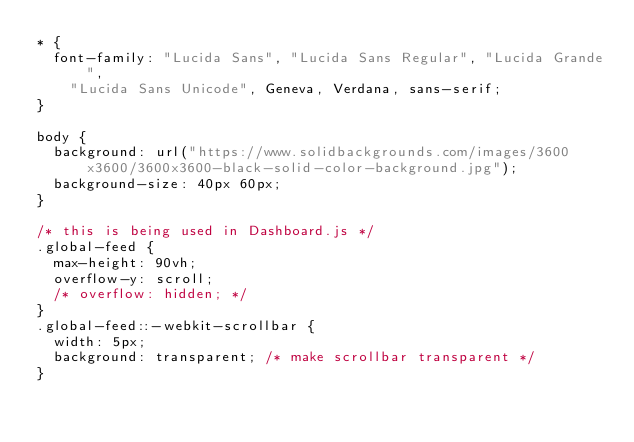<code> <loc_0><loc_0><loc_500><loc_500><_CSS_>* {
  font-family: "Lucida Sans", "Lucida Sans Regular", "Lucida Grande",
    "Lucida Sans Unicode", Geneva, Verdana, sans-serif;
}

body {
  background: url("https://www.solidbackgrounds.com/images/3600x3600/3600x3600-black-solid-color-background.jpg");
  background-size: 40px 60px;
}

/* this is being used in Dashboard.js */
.global-feed {
  max-height: 90vh;
  overflow-y: scroll;
  /* overflow: hidden; */
}
.global-feed::-webkit-scrollbar {
  width: 5px;
  background: transparent; /* make scrollbar transparent */
}
</code> 